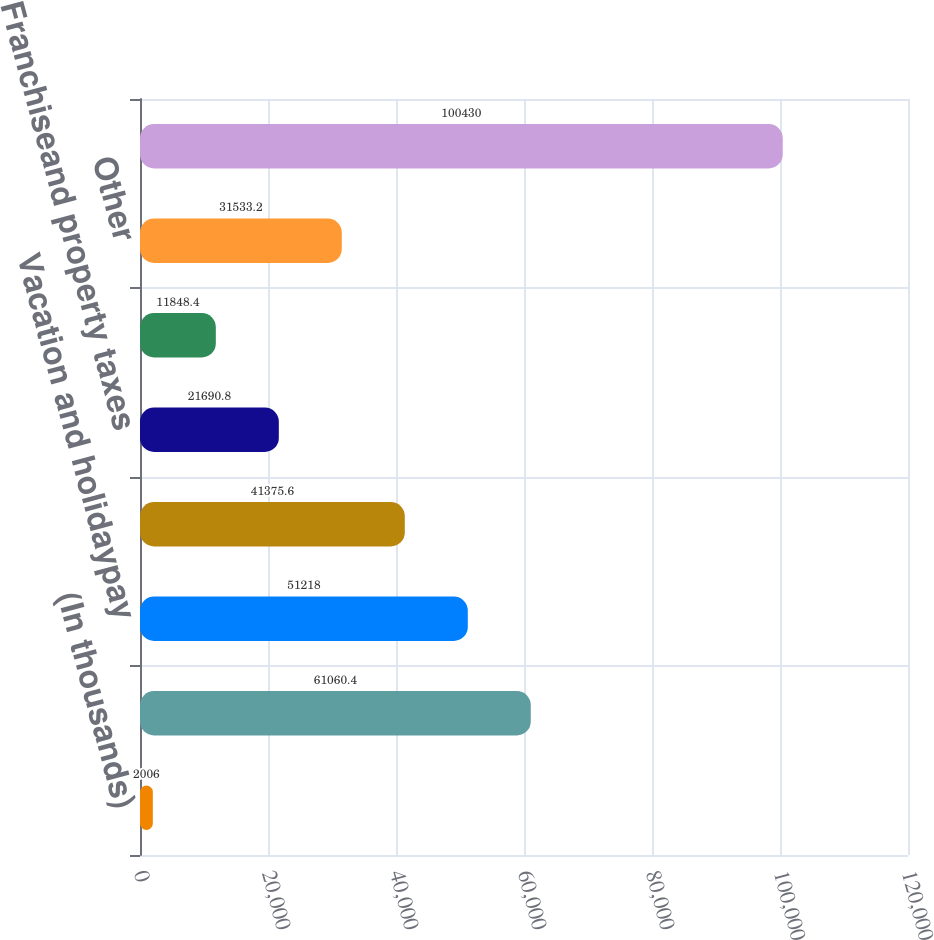<chart> <loc_0><loc_0><loc_500><loc_500><bar_chart><fcel>(In thousands)<fcel>Medical insuranceand workers'<fcel>Vacation and holidaypay<fcel>Customer volume discounts and<fcel>Franchiseand property taxes<fcel>Payrolland payroll taxes<fcel>Other<fcel>Total<nl><fcel>2006<fcel>61060.4<fcel>51218<fcel>41375.6<fcel>21690.8<fcel>11848.4<fcel>31533.2<fcel>100430<nl></chart> 